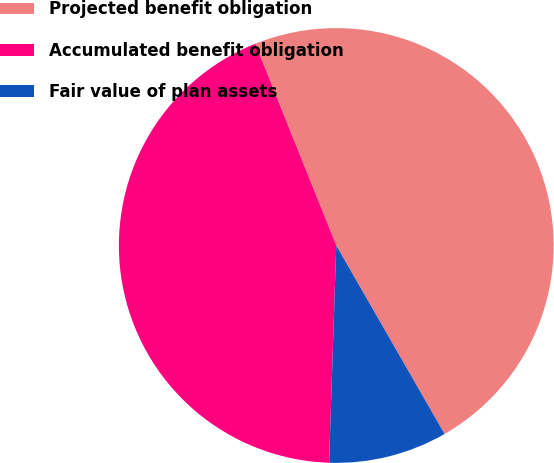Convert chart to OTSL. <chart><loc_0><loc_0><loc_500><loc_500><pie_chart><fcel>Projected benefit obligation<fcel>Accumulated benefit obligation<fcel>Fair value of plan assets<nl><fcel>47.78%<fcel>43.4%<fcel>8.83%<nl></chart> 